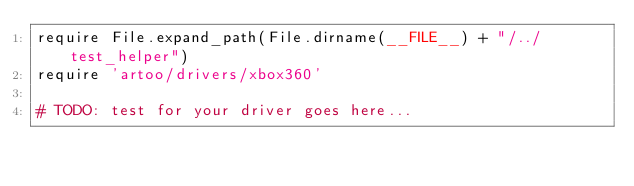<code> <loc_0><loc_0><loc_500><loc_500><_Ruby_>require File.expand_path(File.dirname(__FILE__) + "/../test_helper")
require 'artoo/drivers/xbox360'

# TODO: test for your driver goes here...
</code> 